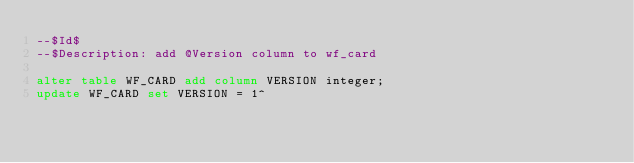Convert code to text. <code><loc_0><loc_0><loc_500><loc_500><_SQL_>--$Id$
--$Description: add @Version column to wf_card

alter table WF_CARD add column VERSION integer;
update WF_CARD set VERSION = 1^

</code> 